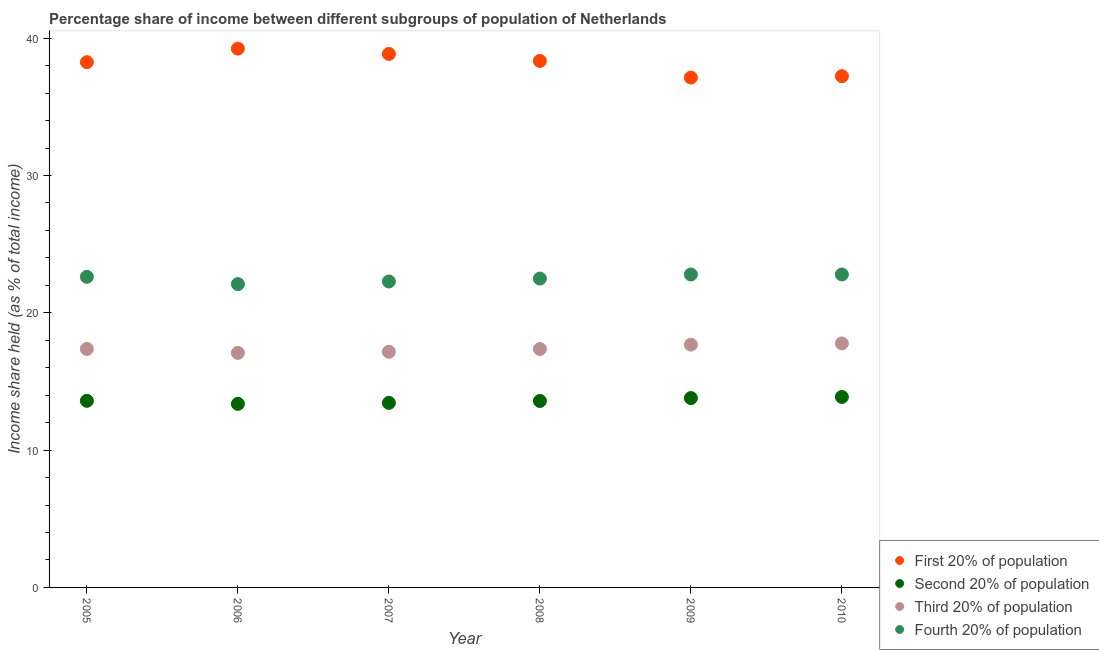How many different coloured dotlines are there?
Provide a succinct answer. 4. Is the number of dotlines equal to the number of legend labels?
Ensure brevity in your answer.  Yes. What is the share of the income held by third 20% of the population in 2009?
Provide a succinct answer. 17.68. Across all years, what is the maximum share of the income held by first 20% of the population?
Ensure brevity in your answer.  39.24. Across all years, what is the minimum share of the income held by fourth 20% of the population?
Your answer should be compact. 22.09. In which year was the share of the income held by fourth 20% of the population maximum?
Give a very brief answer. 2009. In which year was the share of the income held by first 20% of the population minimum?
Keep it short and to the point. 2009. What is the total share of the income held by third 20% of the population in the graph?
Your response must be concise. 104.42. What is the difference between the share of the income held by second 20% of the population in 2007 and that in 2010?
Provide a succinct answer. -0.43. What is the difference between the share of the income held by second 20% of the population in 2010 and the share of the income held by fourth 20% of the population in 2009?
Make the answer very short. -8.92. What is the average share of the income held by first 20% of the population per year?
Your answer should be very brief. 38.17. In the year 2006, what is the difference between the share of the income held by first 20% of the population and share of the income held by fourth 20% of the population?
Provide a short and direct response. 17.15. In how many years, is the share of the income held by fourth 20% of the population greater than 16 %?
Offer a very short reply. 6. What is the ratio of the share of the income held by second 20% of the population in 2007 to that in 2008?
Provide a succinct answer. 0.99. Is the share of the income held by fourth 20% of the population in 2006 less than that in 2010?
Give a very brief answer. Yes. Is the difference between the share of the income held by fourth 20% of the population in 2005 and 2008 greater than the difference between the share of the income held by second 20% of the population in 2005 and 2008?
Ensure brevity in your answer.  Yes. What is the difference between the highest and the second highest share of the income held by fourth 20% of the population?
Provide a short and direct response. 0. What is the difference between the highest and the lowest share of the income held by fourth 20% of the population?
Your answer should be very brief. 0.7. In how many years, is the share of the income held by first 20% of the population greater than the average share of the income held by first 20% of the population taken over all years?
Give a very brief answer. 4. Is it the case that in every year, the sum of the share of the income held by first 20% of the population and share of the income held by fourth 20% of the population is greater than the sum of share of the income held by second 20% of the population and share of the income held by third 20% of the population?
Your answer should be very brief. Yes. Does the share of the income held by first 20% of the population monotonically increase over the years?
Your response must be concise. No. Is the share of the income held by first 20% of the population strictly less than the share of the income held by second 20% of the population over the years?
Ensure brevity in your answer.  No. Are the values on the major ticks of Y-axis written in scientific E-notation?
Your answer should be compact. No. What is the title of the graph?
Keep it short and to the point. Percentage share of income between different subgroups of population of Netherlands. Does "HFC gas" appear as one of the legend labels in the graph?
Give a very brief answer. No. What is the label or title of the Y-axis?
Offer a terse response. Income share held (as % of total income). What is the Income share held (as % of total income) in First 20% of population in 2005?
Provide a short and direct response. 38.25. What is the Income share held (as % of total income) of Second 20% of population in 2005?
Your answer should be very brief. 13.59. What is the Income share held (as % of total income) in Third 20% of population in 2005?
Offer a very short reply. 17.37. What is the Income share held (as % of total income) in Fourth 20% of population in 2005?
Provide a short and direct response. 22.62. What is the Income share held (as % of total income) in First 20% of population in 2006?
Your response must be concise. 39.24. What is the Income share held (as % of total income) in Second 20% of population in 2006?
Give a very brief answer. 13.37. What is the Income share held (as % of total income) in Third 20% of population in 2006?
Keep it short and to the point. 17.08. What is the Income share held (as % of total income) in Fourth 20% of population in 2006?
Provide a succinct answer. 22.09. What is the Income share held (as % of total income) of First 20% of population in 2007?
Provide a succinct answer. 38.85. What is the Income share held (as % of total income) of Second 20% of population in 2007?
Keep it short and to the point. 13.44. What is the Income share held (as % of total income) of Third 20% of population in 2007?
Your answer should be very brief. 17.16. What is the Income share held (as % of total income) in Fourth 20% of population in 2007?
Provide a succinct answer. 22.28. What is the Income share held (as % of total income) in First 20% of population in 2008?
Your answer should be compact. 38.34. What is the Income share held (as % of total income) of Second 20% of population in 2008?
Keep it short and to the point. 13.58. What is the Income share held (as % of total income) of Third 20% of population in 2008?
Offer a terse response. 17.36. What is the Income share held (as % of total income) of Fourth 20% of population in 2008?
Make the answer very short. 22.49. What is the Income share held (as % of total income) in First 20% of population in 2009?
Give a very brief answer. 37.13. What is the Income share held (as % of total income) in Second 20% of population in 2009?
Make the answer very short. 13.79. What is the Income share held (as % of total income) of Third 20% of population in 2009?
Keep it short and to the point. 17.68. What is the Income share held (as % of total income) of Fourth 20% of population in 2009?
Make the answer very short. 22.79. What is the Income share held (as % of total income) in First 20% of population in 2010?
Your response must be concise. 37.23. What is the Income share held (as % of total income) in Second 20% of population in 2010?
Your answer should be compact. 13.87. What is the Income share held (as % of total income) in Third 20% of population in 2010?
Offer a terse response. 17.77. What is the Income share held (as % of total income) in Fourth 20% of population in 2010?
Ensure brevity in your answer.  22.79. Across all years, what is the maximum Income share held (as % of total income) in First 20% of population?
Provide a short and direct response. 39.24. Across all years, what is the maximum Income share held (as % of total income) of Second 20% of population?
Provide a short and direct response. 13.87. Across all years, what is the maximum Income share held (as % of total income) in Third 20% of population?
Ensure brevity in your answer.  17.77. Across all years, what is the maximum Income share held (as % of total income) in Fourth 20% of population?
Provide a succinct answer. 22.79. Across all years, what is the minimum Income share held (as % of total income) in First 20% of population?
Offer a very short reply. 37.13. Across all years, what is the minimum Income share held (as % of total income) of Second 20% of population?
Ensure brevity in your answer.  13.37. Across all years, what is the minimum Income share held (as % of total income) in Third 20% of population?
Provide a succinct answer. 17.08. Across all years, what is the minimum Income share held (as % of total income) in Fourth 20% of population?
Provide a succinct answer. 22.09. What is the total Income share held (as % of total income) of First 20% of population in the graph?
Provide a short and direct response. 229.04. What is the total Income share held (as % of total income) in Second 20% of population in the graph?
Give a very brief answer. 81.64. What is the total Income share held (as % of total income) of Third 20% of population in the graph?
Keep it short and to the point. 104.42. What is the total Income share held (as % of total income) of Fourth 20% of population in the graph?
Provide a succinct answer. 135.06. What is the difference between the Income share held (as % of total income) of First 20% of population in 2005 and that in 2006?
Make the answer very short. -0.99. What is the difference between the Income share held (as % of total income) in Second 20% of population in 2005 and that in 2006?
Your response must be concise. 0.22. What is the difference between the Income share held (as % of total income) in Third 20% of population in 2005 and that in 2006?
Your response must be concise. 0.29. What is the difference between the Income share held (as % of total income) in Fourth 20% of population in 2005 and that in 2006?
Offer a very short reply. 0.53. What is the difference between the Income share held (as % of total income) of Second 20% of population in 2005 and that in 2007?
Provide a short and direct response. 0.15. What is the difference between the Income share held (as % of total income) in Third 20% of population in 2005 and that in 2007?
Make the answer very short. 0.21. What is the difference between the Income share held (as % of total income) of Fourth 20% of population in 2005 and that in 2007?
Offer a terse response. 0.34. What is the difference between the Income share held (as % of total income) in First 20% of population in 2005 and that in 2008?
Your answer should be compact. -0.09. What is the difference between the Income share held (as % of total income) in Second 20% of population in 2005 and that in 2008?
Ensure brevity in your answer.  0.01. What is the difference between the Income share held (as % of total income) in Third 20% of population in 2005 and that in 2008?
Your response must be concise. 0.01. What is the difference between the Income share held (as % of total income) in Fourth 20% of population in 2005 and that in 2008?
Your answer should be very brief. 0.13. What is the difference between the Income share held (as % of total income) of First 20% of population in 2005 and that in 2009?
Your answer should be very brief. 1.12. What is the difference between the Income share held (as % of total income) in Third 20% of population in 2005 and that in 2009?
Make the answer very short. -0.31. What is the difference between the Income share held (as % of total income) of Fourth 20% of population in 2005 and that in 2009?
Your answer should be compact. -0.17. What is the difference between the Income share held (as % of total income) of First 20% of population in 2005 and that in 2010?
Provide a succinct answer. 1.02. What is the difference between the Income share held (as % of total income) in Second 20% of population in 2005 and that in 2010?
Offer a very short reply. -0.28. What is the difference between the Income share held (as % of total income) of Third 20% of population in 2005 and that in 2010?
Provide a short and direct response. -0.4. What is the difference between the Income share held (as % of total income) in Fourth 20% of population in 2005 and that in 2010?
Offer a terse response. -0.17. What is the difference between the Income share held (as % of total income) in First 20% of population in 2006 and that in 2007?
Your answer should be very brief. 0.39. What is the difference between the Income share held (as % of total income) in Second 20% of population in 2006 and that in 2007?
Make the answer very short. -0.07. What is the difference between the Income share held (as % of total income) of Third 20% of population in 2006 and that in 2007?
Give a very brief answer. -0.08. What is the difference between the Income share held (as % of total income) in Fourth 20% of population in 2006 and that in 2007?
Make the answer very short. -0.19. What is the difference between the Income share held (as % of total income) of Second 20% of population in 2006 and that in 2008?
Provide a succinct answer. -0.21. What is the difference between the Income share held (as % of total income) in Third 20% of population in 2006 and that in 2008?
Give a very brief answer. -0.28. What is the difference between the Income share held (as % of total income) in First 20% of population in 2006 and that in 2009?
Offer a terse response. 2.11. What is the difference between the Income share held (as % of total income) of Second 20% of population in 2006 and that in 2009?
Your answer should be very brief. -0.42. What is the difference between the Income share held (as % of total income) of Third 20% of population in 2006 and that in 2009?
Your answer should be compact. -0.6. What is the difference between the Income share held (as % of total income) in Fourth 20% of population in 2006 and that in 2009?
Offer a terse response. -0.7. What is the difference between the Income share held (as % of total income) in First 20% of population in 2006 and that in 2010?
Provide a short and direct response. 2.01. What is the difference between the Income share held (as % of total income) of Third 20% of population in 2006 and that in 2010?
Your answer should be very brief. -0.69. What is the difference between the Income share held (as % of total income) of Fourth 20% of population in 2006 and that in 2010?
Your answer should be compact. -0.7. What is the difference between the Income share held (as % of total income) in First 20% of population in 2007 and that in 2008?
Provide a short and direct response. 0.51. What is the difference between the Income share held (as % of total income) in Second 20% of population in 2007 and that in 2008?
Your answer should be compact. -0.14. What is the difference between the Income share held (as % of total income) in Fourth 20% of population in 2007 and that in 2008?
Provide a short and direct response. -0.21. What is the difference between the Income share held (as % of total income) of First 20% of population in 2007 and that in 2009?
Give a very brief answer. 1.72. What is the difference between the Income share held (as % of total income) of Second 20% of population in 2007 and that in 2009?
Your answer should be very brief. -0.35. What is the difference between the Income share held (as % of total income) of Third 20% of population in 2007 and that in 2009?
Your answer should be compact. -0.52. What is the difference between the Income share held (as % of total income) in Fourth 20% of population in 2007 and that in 2009?
Your answer should be very brief. -0.51. What is the difference between the Income share held (as % of total income) of First 20% of population in 2007 and that in 2010?
Make the answer very short. 1.62. What is the difference between the Income share held (as % of total income) of Second 20% of population in 2007 and that in 2010?
Offer a very short reply. -0.43. What is the difference between the Income share held (as % of total income) in Third 20% of population in 2007 and that in 2010?
Ensure brevity in your answer.  -0.61. What is the difference between the Income share held (as % of total income) in Fourth 20% of population in 2007 and that in 2010?
Ensure brevity in your answer.  -0.51. What is the difference between the Income share held (as % of total income) in First 20% of population in 2008 and that in 2009?
Make the answer very short. 1.21. What is the difference between the Income share held (as % of total income) of Second 20% of population in 2008 and that in 2009?
Offer a very short reply. -0.21. What is the difference between the Income share held (as % of total income) in Third 20% of population in 2008 and that in 2009?
Provide a short and direct response. -0.32. What is the difference between the Income share held (as % of total income) of Fourth 20% of population in 2008 and that in 2009?
Provide a succinct answer. -0.3. What is the difference between the Income share held (as % of total income) in First 20% of population in 2008 and that in 2010?
Offer a terse response. 1.11. What is the difference between the Income share held (as % of total income) in Second 20% of population in 2008 and that in 2010?
Provide a short and direct response. -0.29. What is the difference between the Income share held (as % of total income) of Third 20% of population in 2008 and that in 2010?
Provide a short and direct response. -0.41. What is the difference between the Income share held (as % of total income) in Fourth 20% of population in 2008 and that in 2010?
Your answer should be compact. -0.3. What is the difference between the Income share held (as % of total income) of First 20% of population in 2009 and that in 2010?
Offer a very short reply. -0.1. What is the difference between the Income share held (as % of total income) in Second 20% of population in 2009 and that in 2010?
Make the answer very short. -0.08. What is the difference between the Income share held (as % of total income) of Third 20% of population in 2009 and that in 2010?
Make the answer very short. -0.09. What is the difference between the Income share held (as % of total income) of Fourth 20% of population in 2009 and that in 2010?
Ensure brevity in your answer.  0. What is the difference between the Income share held (as % of total income) of First 20% of population in 2005 and the Income share held (as % of total income) of Second 20% of population in 2006?
Make the answer very short. 24.88. What is the difference between the Income share held (as % of total income) in First 20% of population in 2005 and the Income share held (as % of total income) in Third 20% of population in 2006?
Ensure brevity in your answer.  21.17. What is the difference between the Income share held (as % of total income) in First 20% of population in 2005 and the Income share held (as % of total income) in Fourth 20% of population in 2006?
Offer a very short reply. 16.16. What is the difference between the Income share held (as % of total income) in Second 20% of population in 2005 and the Income share held (as % of total income) in Third 20% of population in 2006?
Your answer should be very brief. -3.49. What is the difference between the Income share held (as % of total income) in Third 20% of population in 2005 and the Income share held (as % of total income) in Fourth 20% of population in 2006?
Keep it short and to the point. -4.72. What is the difference between the Income share held (as % of total income) of First 20% of population in 2005 and the Income share held (as % of total income) of Second 20% of population in 2007?
Offer a very short reply. 24.81. What is the difference between the Income share held (as % of total income) of First 20% of population in 2005 and the Income share held (as % of total income) of Third 20% of population in 2007?
Provide a short and direct response. 21.09. What is the difference between the Income share held (as % of total income) of First 20% of population in 2005 and the Income share held (as % of total income) of Fourth 20% of population in 2007?
Your answer should be compact. 15.97. What is the difference between the Income share held (as % of total income) of Second 20% of population in 2005 and the Income share held (as % of total income) of Third 20% of population in 2007?
Your response must be concise. -3.57. What is the difference between the Income share held (as % of total income) in Second 20% of population in 2005 and the Income share held (as % of total income) in Fourth 20% of population in 2007?
Provide a short and direct response. -8.69. What is the difference between the Income share held (as % of total income) of Third 20% of population in 2005 and the Income share held (as % of total income) of Fourth 20% of population in 2007?
Give a very brief answer. -4.91. What is the difference between the Income share held (as % of total income) in First 20% of population in 2005 and the Income share held (as % of total income) in Second 20% of population in 2008?
Provide a short and direct response. 24.67. What is the difference between the Income share held (as % of total income) in First 20% of population in 2005 and the Income share held (as % of total income) in Third 20% of population in 2008?
Provide a succinct answer. 20.89. What is the difference between the Income share held (as % of total income) of First 20% of population in 2005 and the Income share held (as % of total income) of Fourth 20% of population in 2008?
Give a very brief answer. 15.76. What is the difference between the Income share held (as % of total income) in Second 20% of population in 2005 and the Income share held (as % of total income) in Third 20% of population in 2008?
Your answer should be very brief. -3.77. What is the difference between the Income share held (as % of total income) in Third 20% of population in 2005 and the Income share held (as % of total income) in Fourth 20% of population in 2008?
Keep it short and to the point. -5.12. What is the difference between the Income share held (as % of total income) in First 20% of population in 2005 and the Income share held (as % of total income) in Second 20% of population in 2009?
Provide a short and direct response. 24.46. What is the difference between the Income share held (as % of total income) of First 20% of population in 2005 and the Income share held (as % of total income) of Third 20% of population in 2009?
Your answer should be very brief. 20.57. What is the difference between the Income share held (as % of total income) of First 20% of population in 2005 and the Income share held (as % of total income) of Fourth 20% of population in 2009?
Offer a very short reply. 15.46. What is the difference between the Income share held (as % of total income) in Second 20% of population in 2005 and the Income share held (as % of total income) in Third 20% of population in 2009?
Keep it short and to the point. -4.09. What is the difference between the Income share held (as % of total income) in Second 20% of population in 2005 and the Income share held (as % of total income) in Fourth 20% of population in 2009?
Offer a terse response. -9.2. What is the difference between the Income share held (as % of total income) in Third 20% of population in 2005 and the Income share held (as % of total income) in Fourth 20% of population in 2009?
Offer a terse response. -5.42. What is the difference between the Income share held (as % of total income) of First 20% of population in 2005 and the Income share held (as % of total income) of Second 20% of population in 2010?
Keep it short and to the point. 24.38. What is the difference between the Income share held (as % of total income) in First 20% of population in 2005 and the Income share held (as % of total income) in Third 20% of population in 2010?
Provide a short and direct response. 20.48. What is the difference between the Income share held (as % of total income) in First 20% of population in 2005 and the Income share held (as % of total income) in Fourth 20% of population in 2010?
Make the answer very short. 15.46. What is the difference between the Income share held (as % of total income) of Second 20% of population in 2005 and the Income share held (as % of total income) of Third 20% of population in 2010?
Keep it short and to the point. -4.18. What is the difference between the Income share held (as % of total income) in Third 20% of population in 2005 and the Income share held (as % of total income) in Fourth 20% of population in 2010?
Ensure brevity in your answer.  -5.42. What is the difference between the Income share held (as % of total income) in First 20% of population in 2006 and the Income share held (as % of total income) in Second 20% of population in 2007?
Ensure brevity in your answer.  25.8. What is the difference between the Income share held (as % of total income) in First 20% of population in 2006 and the Income share held (as % of total income) in Third 20% of population in 2007?
Offer a very short reply. 22.08. What is the difference between the Income share held (as % of total income) of First 20% of population in 2006 and the Income share held (as % of total income) of Fourth 20% of population in 2007?
Your answer should be compact. 16.96. What is the difference between the Income share held (as % of total income) of Second 20% of population in 2006 and the Income share held (as % of total income) of Third 20% of population in 2007?
Your answer should be compact. -3.79. What is the difference between the Income share held (as % of total income) of Second 20% of population in 2006 and the Income share held (as % of total income) of Fourth 20% of population in 2007?
Give a very brief answer. -8.91. What is the difference between the Income share held (as % of total income) of Third 20% of population in 2006 and the Income share held (as % of total income) of Fourth 20% of population in 2007?
Ensure brevity in your answer.  -5.2. What is the difference between the Income share held (as % of total income) in First 20% of population in 2006 and the Income share held (as % of total income) in Second 20% of population in 2008?
Give a very brief answer. 25.66. What is the difference between the Income share held (as % of total income) in First 20% of population in 2006 and the Income share held (as % of total income) in Third 20% of population in 2008?
Offer a very short reply. 21.88. What is the difference between the Income share held (as % of total income) in First 20% of population in 2006 and the Income share held (as % of total income) in Fourth 20% of population in 2008?
Your response must be concise. 16.75. What is the difference between the Income share held (as % of total income) in Second 20% of population in 2006 and the Income share held (as % of total income) in Third 20% of population in 2008?
Provide a short and direct response. -3.99. What is the difference between the Income share held (as % of total income) in Second 20% of population in 2006 and the Income share held (as % of total income) in Fourth 20% of population in 2008?
Keep it short and to the point. -9.12. What is the difference between the Income share held (as % of total income) of Third 20% of population in 2006 and the Income share held (as % of total income) of Fourth 20% of population in 2008?
Offer a terse response. -5.41. What is the difference between the Income share held (as % of total income) in First 20% of population in 2006 and the Income share held (as % of total income) in Second 20% of population in 2009?
Offer a terse response. 25.45. What is the difference between the Income share held (as % of total income) in First 20% of population in 2006 and the Income share held (as % of total income) in Third 20% of population in 2009?
Offer a terse response. 21.56. What is the difference between the Income share held (as % of total income) in First 20% of population in 2006 and the Income share held (as % of total income) in Fourth 20% of population in 2009?
Make the answer very short. 16.45. What is the difference between the Income share held (as % of total income) in Second 20% of population in 2006 and the Income share held (as % of total income) in Third 20% of population in 2009?
Ensure brevity in your answer.  -4.31. What is the difference between the Income share held (as % of total income) of Second 20% of population in 2006 and the Income share held (as % of total income) of Fourth 20% of population in 2009?
Offer a terse response. -9.42. What is the difference between the Income share held (as % of total income) in Third 20% of population in 2006 and the Income share held (as % of total income) in Fourth 20% of population in 2009?
Your answer should be very brief. -5.71. What is the difference between the Income share held (as % of total income) of First 20% of population in 2006 and the Income share held (as % of total income) of Second 20% of population in 2010?
Offer a very short reply. 25.37. What is the difference between the Income share held (as % of total income) in First 20% of population in 2006 and the Income share held (as % of total income) in Third 20% of population in 2010?
Your answer should be very brief. 21.47. What is the difference between the Income share held (as % of total income) of First 20% of population in 2006 and the Income share held (as % of total income) of Fourth 20% of population in 2010?
Offer a very short reply. 16.45. What is the difference between the Income share held (as % of total income) in Second 20% of population in 2006 and the Income share held (as % of total income) in Third 20% of population in 2010?
Ensure brevity in your answer.  -4.4. What is the difference between the Income share held (as % of total income) of Second 20% of population in 2006 and the Income share held (as % of total income) of Fourth 20% of population in 2010?
Give a very brief answer. -9.42. What is the difference between the Income share held (as % of total income) in Third 20% of population in 2006 and the Income share held (as % of total income) in Fourth 20% of population in 2010?
Your response must be concise. -5.71. What is the difference between the Income share held (as % of total income) in First 20% of population in 2007 and the Income share held (as % of total income) in Second 20% of population in 2008?
Ensure brevity in your answer.  25.27. What is the difference between the Income share held (as % of total income) in First 20% of population in 2007 and the Income share held (as % of total income) in Third 20% of population in 2008?
Your response must be concise. 21.49. What is the difference between the Income share held (as % of total income) in First 20% of population in 2007 and the Income share held (as % of total income) in Fourth 20% of population in 2008?
Ensure brevity in your answer.  16.36. What is the difference between the Income share held (as % of total income) in Second 20% of population in 2007 and the Income share held (as % of total income) in Third 20% of population in 2008?
Your answer should be compact. -3.92. What is the difference between the Income share held (as % of total income) in Second 20% of population in 2007 and the Income share held (as % of total income) in Fourth 20% of population in 2008?
Provide a succinct answer. -9.05. What is the difference between the Income share held (as % of total income) in Third 20% of population in 2007 and the Income share held (as % of total income) in Fourth 20% of population in 2008?
Give a very brief answer. -5.33. What is the difference between the Income share held (as % of total income) of First 20% of population in 2007 and the Income share held (as % of total income) of Second 20% of population in 2009?
Provide a short and direct response. 25.06. What is the difference between the Income share held (as % of total income) of First 20% of population in 2007 and the Income share held (as % of total income) of Third 20% of population in 2009?
Keep it short and to the point. 21.17. What is the difference between the Income share held (as % of total income) of First 20% of population in 2007 and the Income share held (as % of total income) of Fourth 20% of population in 2009?
Provide a short and direct response. 16.06. What is the difference between the Income share held (as % of total income) in Second 20% of population in 2007 and the Income share held (as % of total income) in Third 20% of population in 2009?
Your answer should be compact. -4.24. What is the difference between the Income share held (as % of total income) in Second 20% of population in 2007 and the Income share held (as % of total income) in Fourth 20% of population in 2009?
Your answer should be very brief. -9.35. What is the difference between the Income share held (as % of total income) of Third 20% of population in 2007 and the Income share held (as % of total income) of Fourth 20% of population in 2009?
Give a very brief answer. -5.63. What is the difference between the Income share held (as % of total income) of First 20% of population in 2007 and the Income share held (as % of total income) of Second 20% of population in 2010?
Give a very brief answer. 24.98. What is the difference between the Income share held (as % of total income) in First 20% of population in 2007 and the Income share held (as % of total income) in Third 20% of population in 2010?
Provide a short and direct response. 21.08. What is the difference between the Income share held (as % of total income) of First 20% of population in 2007 and the Income share held (as % of total income) of Fourth 20% of population in 2010?
Make the answer very short. 16.06. What is the difference between the Income share held (as % of total income) in Second 20% of population in 2007 and the Income share held (as % of total income) in Third 20% of population in 2010?
Your response must be concise. -4.33. What is the difference between the Income share held (as % of total income) in Second 20% of population in 2007 and the Income share held (as % of total income) in Fourth 20% of population in 2010?
Your answer should be very brief. -9.35. What is the difference between the Income share held (as % of total income) in Third 20% of population in 2007 and the Income share held (as % of total income) in Fourth 20% of population in 2010?
Provide a short and direct response. -5.63. What is the difference between the Income share held (as % of total income) of First 20% of population in 2008 and the Income share held (as % of total income) of Second 20% of population in 2009?
Make the answer very short. 24.55. What is the difference between the Income share held (as % of total income) of First 20% of population in 2008 and the Income share held (as % of total income) of Third 20% of population in 2009?
Give a very brief answer. 20.66. What is the difference between the Income share held (as % of total income) of First 20% of population in 2008 and the Income share held (as % of total income) of Fourth 20% of population in 2009?
Provide a short and direct response. 15.55. What is the difference between the Income share held (as % of total income) in Second 20% of population in 2008 and the Income share held (as % of total income) in Fourth 20% of population in 2009?
Provide a succinct answer. -9.21. What is the difference between the Income share held (as % of total income) in Third 20% of population in 2008 and the Income share held (as % of total income) in Fourth 20% of population in 2009?
Provide a succinct answer. -5.43. What is the difference between the Income share held (as % of total income) of First 20% of population in 2008 and the Income share held (as % of total income) of Second 20% of population in 2010?
Offer a very short reply. 24.47. What is the difference between the Income share held (as % of total income) in First 20% of population in 2008 and the Income share held (as % of total income) in Third 20% of population in 2010?
Offer a terse response. 20.57. What is the difference between the Income share held (as % of total income) in First 20% of population in 2008 and the Income share held (as % of total income) in Fourth 20% of population in 2010?
Ensure brevity in your answer.  15.55. What is the difference between the Income share held (as % of total income) of Second 20% of population in 2008 and the Income share held (as % of total income) of Third 20% of population in 2010?
Your response must be concise. -4.19. What is the difference between the Income share held (as % of total income) in Second 20% of population in 2008 and the Income share held (as % of total income) in Fourth 20% of population in 2010?
Offer a very short reply. -9.21. What is the difference between the Income share held (as % of total income) in Third 20% of population in 2008 and the Income share held (as % of total income) in Fourth 20% of population in 2010?
Offer a very short reply. -5.43. What is the difference between the Income share held (as % of total income) of First 20% of population in 2009 and the Income share held (as % of total income) of Second 20% of population in 2010?
Ensure brevity in your answer.  23.26. What is the difference between the Income share held (as % of total income) of First 20% of population in 2009 and the Income share held (as % of total income) of Third 20% of population in 2010?
Offer a terse response. 19.36. What is the difference between the Income share held (as % of total income) in First 20% of population in 2009 and the Income share held (as % of total income) in Fourth 20% of population in 2010?
Provide a short and direct response. 14.34. What is the difference between the Income share held (as % of total income) in Second 20% of population in 2009 and the Income share held (as % of total income) in Third 20% of population in 2010?
Your answer should be compact. -3.98. What is the difference between the Income share held (as % of total income) in Third 20% of population in 2009 and the Income share held (as % of total income) in Fourth 20% of population in 2010?
Keep it short and to the point. -5.11. What is the average Income share held (as % of total income) of First 20% of population per year?
Your response must be concise. 38.17. What is the average Income share held (as % of total income) of Second 20% of population per year?
Offer a very short reply. 13.61. What is the average Income share held (as % of total income) of Third 20% of population per year?
Offer a terse response. 17.4. What is the average Income share held (as % of total income) in Fourth 20% of population per year?
Keep it short and to the point. 22.51. In the year 2005, what is the difference between the Income share held (as % of total income) in First 20% of population and Income share held (as % of total income) in Second 20% of population?
Offer a very short reply. 24.66. In the year 2005, what is the difference between the Income share held (as % of total income) of First 20% of population and Income share held (as % of total income) of Third 20% of population?
Provide a succinct answer. 20.88. In the year 2005, what is the difference between the Income share held (as % of total income) of First 20% of population and Income share held (as % of total income) of Fourth 20% of population?
Give a very brief answer. 15.63. In the year 2005, what is the difference between the Income share held (as % of total income) of Second 20% of population and Income share held (as % of total income) of Third 20% of population?
Keep it short and to the point. -3.78. In the year 2005, what is the difference between the Income share held (as % of total income) of Second 20% of population and Income share held (as % of total income) of Fourth 20% of population?
Your answer should be very brief. -9.03. In the year 2005, what is the difference between the Income share held (as % of total income) of Third 20% of population and Income share held (as % of total income) of Fourth 20% of population?
Your answer should be very brief. -5.25. In the year 2006, what is the difference between the Income share held (as % of total income) in First 20% of population and Income share held (as % of total income) in Second 20% of population?
Ensure brevity in your answer.  25.87. In the year 2006, what is the difference between the Income share held (as % of total income) in First 20% of population and Income share held (as % of total income) in Third 20% of population?
Offer a terse response. 22.16. In the year 2006, what is the difference between the Income share held (as % of total income) of First 20% of population and Income share held (as % of total income) of Fourth 20% of population?
Make the answer very short. 17.15. In the year 2006, what is the difference between the Income share held (as % of total income) in Second 20% of population and Income share held (as % of total income) in Third 20% of population?
Your answer should be compact. -3.71. In the year 2006, what is the difference between the Income share held (as % of total income) of Second 20% of population and Income share held (as % of total income) of Fourth 20% of population?
Your answer should be very brief. -8.72. In the year 2006, what is the difference between the Income share held (as % of total income) in Third 20% of population and Income share held (as % of total income) in Fourth 20% of population?
Your answer should be compact. -5.01. In the year 2007, what is the difference between the Income share held (as % of total income) of First 20% of population and Income share held (as % of total income) of Second 20% of population?
Give a very brief answer. 25.41. In the year 2007, what is the difference between the Income share held (as % of total income) of First 20% of population and Income share held (as % of total income) of Third 20% of population?
Your answer should be very brief. 21.69. In the year 2007, what is the difference between the Income share held (as % of total income) in First 20% of population and Income share held (as % of total income) in Fourth 20% of population?
Your response must be concise. 16.57. In the year 2007, what is the difference between the Income share held (as % of total income) of Second 20% of population and Income share held (as % of total income) of Third 20% of population?
Provide a short and direct response. -3.72. In the year 2007, what is the difference between the Income share held (as % of total income) of Second 20% of population and Income share held (as % of total income) of Fourth 20% of population?
Give a very brief answer. -8.84. In the year 2007, what is the difference between the Income share held (as % of total income) of Third 20% of population and Income share held (as % of total income) of Fourth 20% of population?
Your answer should be very brief. -5.12. In the year 2008, what is the difference between the Income share held (as % of total income) of First 20% of population and Income share held (as % of total income) of Second 20% of population?
Provide a short and direct response. 24.76. In the year 2008, what is the difference between the Income share held (as % of total income) of First 20% of population and Income share held (as % of total income) of Third 20% of population?
Make the answer very short. 20.98. In the year 2008, what is the difference between the Income share held (as % of total income) of First 20% of population and Income share held (as % of total income) of Fourth 20% of population?
Your answer should be very brief. 15.85. In the year 2008, what is the difference between the Income share held (as % of total income) of Second 20% of population and Income share held (as % of total income) of Third 20% of population?
Offer a terse response. -3.78. In the year 2008, what is the difference between the Income share held (as % of total income) of Second 20% of population and Income share held (as % of total income) of Fourth 20% of population?
Keep it short and to the point. -8.91. In the year 2008, what is the difference between the Income share held (as % of total income) in Third 20% of population and Income share held (as % of total income) in Fourth 20% of population?
Keep it short and to the point. -5.13. In the year 2009, what is the difference between the Income share held (as % of total income) in First 20% of population and Income share held (as % of total income) in Second 20% of population?
Your response must be concise. 23.34. In the year 2009, what is the difference between the Income share held (as % of total income) of First 20% of population and Income share held (as % of total income) of Third 20% of population?
Your answer should be very brief. 19.45. In the year 2009, what is the difference between the Income share held (as % of total income) in First 20% of population and Income share held (as % of total income) in Fourth 20% of population?
Make the answer very short. 14.34. In the year 2009, what is the difference between the Income share held (as % of total income) in Second 20% of population and Income share held (as % of total income) in Third 20% of population?
Your response must be concise. -3.89. In the year 2009, what is the difference between the Income share held (as % of total income) of Third 20% of population and Income share held (as % of total income) of Fourth 20% of population?
Make the answer very short. -5.11. In the year 2010, what is the difference between the Income share held (as % of total income) of First 20% of population and Income share held (as % of total income) of Second 20% of population?
Provide a short and direct response. 23.36. In the year 2010, what is the difference between the Income share held (as % of total income) in First 20% of population and Income share held (as % of total income) in Third 20% of population?
Ensure brevity in your answer.  19.46. In the year 2010, what is the difference between the Income share held (as % of total income) in First 20% of population and Income share held (as % of total income) in Fourth 20% of population?
Give a very brief answer. 14.44. In the year 2010, what is the difference between the Income share held (as % of total income) of Second 20% of population and Income share held (as % of total income) of Third 20% of population?
Make the answer very short. -3.9. In the year 2010, what is the difference between the Income share held (as % of total income) of Second 20% of population and Income share held (as % of total income) of Fourth 20% of population?
Your response must be concise. -8.92. In the year 2010, what is the difference between the Income share held (as % of total income) in Third 20% of population and Income share held (as % of total income) in Fourth 20% of population?
Your response must be concise. -5.02. What is the ratio of the Income share held (as % of total income) of First 20% of population in 2005 to that in 2006?
Make the answer very short. 0.97. What is the ratio of the Income share held (as % of total income) in Second 20% of population in 2005 to that in 2006?
Make the answer very short. 1.02. What is the ratio of the Income share held (as % of total income) in Third 20% of population in 2005 to that in 2006?
Keep it short and to the point. 1.02. What is the ratio of the Income share held (as % of total income) of Fourth 20% of population in 2005 to that in 2006?
Your response must be concise. 1.02. What is the ratio of the Income share held (as % of total income) of First 20% of population in 2005 to that in 2007?
Keep it short and to the point. 0.98. What is the ratio of the Income share held (as % of total income) in Second 20% of population in 2005 to that in 2007?
Provide a succinct answer. 1.01. What is the ratio of the Income share held (as % of total income) in Third 20% of population in 2005 to that in 2007?
Offer a terse response. 1.01. What is the ratio of the Income share held (as % of total income) in Fourth 20% of population in 2005 to that in 2007?
Make the answer very short. 1.02. What is the ratio of the Income share held (as % of total income) of Third 20% of population in 2005 to that in 2008?
Give a very brief answer. 1. What is the ratio of the Income share held (as % of total income) in Fourth 20% of population in 2005 to that in 2008?
Give a very brief answer. 1.01. What is the ratio of the Income share held (as % of total income) of First 20% of population in 2005 to that in 2009?
Keep it short and to the point. 1.03. What is the ratio of the Income share held (as % of total income) in Second 20% of population in 2005 to that in 2009?
Provide a succinct answer. 0.99. What is the ratio of the Income share held (as % of total income) in Third 20% of population in 2005 to that in 2009?
Give a very brief answer. 0.98. What is the ratio of the Income share held (as % of total income) in Fourth 20% of population in 2005 to that in 2009?
Provide a short and direct response. 0.99. What is the ratio of the Income share held (as % of total income) of First 20% of population in 2005 to that in 2010?
Your answer should be very brief. 1.03. What is the ratio of the Income share held (as % of total income) in Second 20% of population in 2005 to that in 2010?
Provide a succinct answer. 0.98. What is the ratio of the Income share held (as % of total income) in Third 20% of population in 2005 to that in 2010?
Offer a very short reply. 0.98. What is the ratio of the Income share held (as % of total income) of First 20% of population in 2006 to that in 2007?
Ensure brevity in your answer.  1.01. What is the ratio of the Income share held (as % of total income) of First 20% of population in 2006 to that in 2008?
Your answer should be compact. 1.02. What is the ratio of the Income share held (as % of total income) of Second 20% of population in 2006 to that in 2008?
Offer a very short reply. 0.98. What is the ratio of the Income share held (as % of total income) of Third 20% of population in 2006 to that in 2008?
Your answer should be compact. 0.98. What is the ratio of the Income share held (as % of total income) in Fourth 20% of population in 2006 to that in 2008?
Your response must be concise. 0.98. What is the ratio of the Income share held (as % of total income) of First 20% of population in 2006 to that in 2009?
Provide a short and direct response. 1.06. What is the ratio of the Income share held (as % of total income) in Second 20% of population in 2006 to that in 2009?
Your response must be concise. 0.97. What is the ratio of the Income share held (as % of total income) of Third 20% of population in 2006 to that in 2009?
Make the answer very short. 0.97. What is the ratio of the Income share held (as % of total income) of Fourth 20% of population in 2006 to that in 2009?
Make the answer very short. 0.97. What is the ratio of the Income share held (as % of total income) of First 20% of population in 2006 to that in 2010?
Give a very brief answer. 1.05. What is the ratio of the Income share held (as % of total income) of Third 20% of population in 2006 to that in 2010?
Make the answer very short. 0.96. What is the ratio of the Income share held (as % of total income) of Fourth 20% of population in 2006 to that in 2010?
Provide a succinct answer. 0.97. What is the ratio of the Income share held (as % of total income) in First 20% of population in 2007 to that in 2008?
Your answer should be very brief. 1.01. What is the ratio of the Income share held (as % of total income) in Fourth 20% of population in 2007 to that in 2008?
Keep it short and to the point. 0.99. What is the ratio of the Income share held (as % of total income) in First 20% of population in 2007 to that in 2009?
Provide a short and direct response. 1.05. What is the ratio of the Income share held (as % of total income) of Second 20% of population in 2007 to that in 2009?
Your answer should be compact. 0.97. What is the ratio of the Income share held (as % of total income) in Third 20% of population in 2007 to that in 2009?
Make the answer very short. 0.97. What is the ratio of the Income share held (as % of total income) in Fourth 20% of population in 2007 to that in 2009?
Keep it short and to the point. 0.98. What is the ratio of the Income share held (as % of total income) of First 20% of population in 2007 to that in 2010?
Make the answer very short. 1.04. What is the ratio of the Income share held (as % of total income) in Third 20% of population in 2007 to that in 2010?
Your answer should be very brief. 0.97. What is the ratio of the Income share held (as % of total income) in Fourth 20% of population in 2007 to that in 2010?
Offer a very short reply. 0.98. What is the ratio of the Income share held (as % of total income) of First 20% of population in 2008 to that in 2009?
Give a very brief answer. 1.03. What is the ratio of the Income share held (as % of total income) of Third 20% of population in 2008 to that in 2009?
Give a very brief answer. 0.98. What is the ratio of the Income share held (as % of total income) in Fourth 20% of population in 2008 to that in 2009?
Your answer should be compact. 0.99. What is the ratio of the Income share held (as % of total income) in First 20% of population in 2008 to that in 2010?
Keep it short and to the point. 1.03. What is the ratio of the Income share held (as % of total income) in Second 20% of population in 2008 to that in 2010?
Offer a terse response. 0.98. What is the ratio of the Income share held (as % of total income) of Third 20% of population in 2008 to that in 2010?
Keep it short and to the point. 0.98. What is the ratio of the Income share held (as % of total income) in Fourth 20% of population in 2008 to that in 2010?
Offer a terse response. 0.99. What is the difference between the highest and the second highest Income share held (as % of total income) of First 20% of population?
Your answer should be compact. 0.39. What is the difference between the highest and the second highest Income share held (as % of total income) of Second 20% of population?
Provide a short and direct response. 0.08. What is the difference between the highest and the second highest Income share held (as % of total income) of Third 20% of population?
Your answer should be very brief. 0.09. What is the difference between the highest and the lowest Income share held (as % of total income) of First 20% of population?
Offer a terse response. 2.11. What is the difference between the highest and the lowest Income share held (as % of total income) of Third 20% of population?
Make the answer very short. 0.69. 